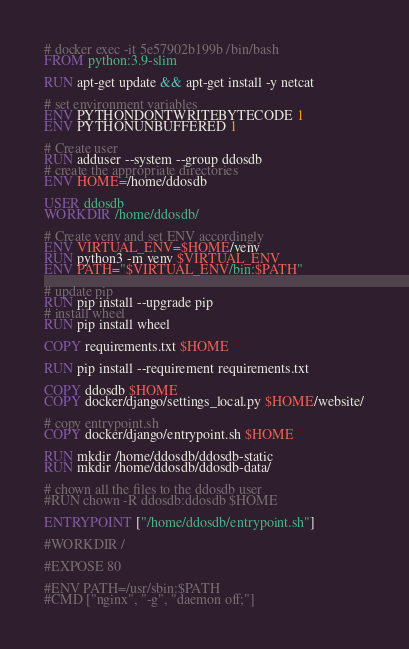Convert code to text. <code><loc_0><loc_0><loc_500><loc_500><_Dockerfile_># docker exec -it 5e57902b199b /bin/bash
FROM python:3.9-slim

RUN apt-get update && apt-get install -y netcat

# set environment variables
ENV PYTHONDONTWRITEBYTECODE 1
ENV PYTHONUNBUFFERED 1

# Create user
RUN adduser --system --group ddosdb
# create the appropriate directories
ENV HOME=/home/ddosdb

USER ddosdb
WORKDIR /home/ddosdb/

# Create venv and set ENV accordingly
ENV VIRTUAL_ENV=$HOME/venv
RUN python3 -m venv $VIRTUAL_ENV
ENV PATH="$VIRTUAL_ENV/bin:$PATH"

# update pip
RUN pip install --upgrade pip
# install wheel
RUN pip install wheel

COPY requirements.txt $HOME

RUN pip install --requirement requirements.txt

COPY ddosdb $HOME
COPY docker/django/settings_local.py $HOME/website/

# copy entrypoint.sh
COPY docker/django/entrypoint.sh $HOME

RUN mkdir /home/ddosdb/ddosdb-static
RUN mkdir /home/ddosdb/ddosdb-data/

# chown all the files to the ddosdb user
#RUN chown -R ddosdb:ddosdb $HOME

ENTRYPOINT ["/home/ddosdb/entrypoint.sh"]

#WORKDIR /

#EXPOSE 80

#ENV PATH=/usr/sbin:$PATH
#CMD ["nginx", "-g", "daemon off;"]
</code> 